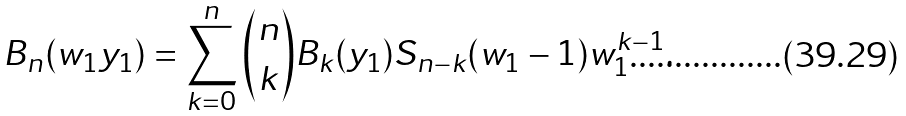<formula> <loc_0><loc_0><loc_500><loc_500>B _ { n } ( w _ { 1 } y _ { 1 } ) = \sum _ { k = 0 } ^ { n } \binom { n } { k } B _ { k } ( y _ { 1 } ) S _ { n - k } ( w _ { 1 } - 1 ) w _ { 1 } ^ { k - 1 } . \\</formula> 